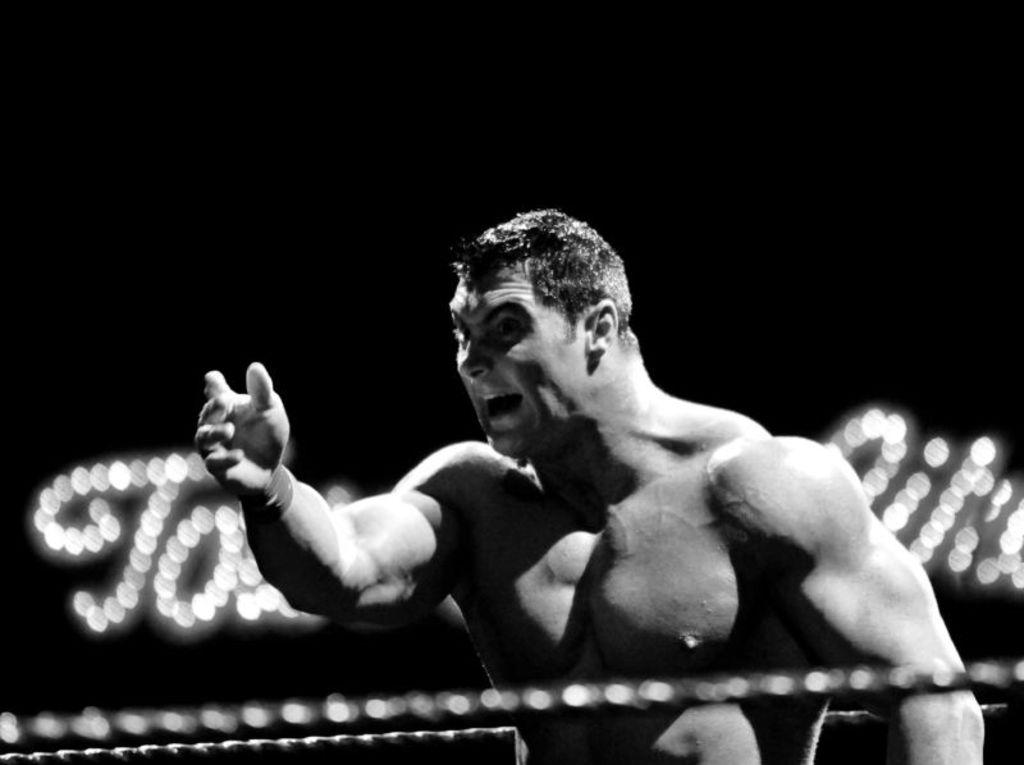What type of picture is in the image? The image contains a black and white picture of a person. What can be seen in the background of the picture? There are ropes and lights in the background of the image. How many ears of corn are visible in the image? There are no ears of corn present in the image. What type of furniture can be seen in the image? There is no furniture present in the image. 